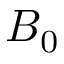<formula> <loc_0><loc_0><loc_500><loc_500>B _ { 0 }</formula> 